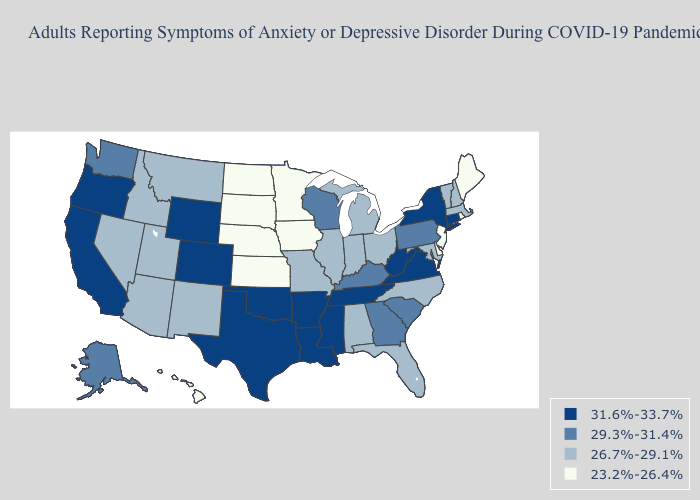Does West Virginia have the lowest value in the South?
Short answer required. No. Which states have the lowest value in the West?
Answer briefly. Hawaii. Among the states that border Wisconsin , does Michigan have the lowest value?
Short answer required. No. Which states have the lowest value in the MidWest?
Quick response, please. Iowa, Kansas, Minnesota, Nebraska, North Dakota, South Dakota. Name the states that have a value in the range 23.2%-26.4%?
Concise answer only. Delaware, Hawaii, Iowa, Kansas, Maine, Minnesota, Nebraska, New Jersey, North Dakota, Rhode Island, South Dakota. What is the highest value in the South ?
Concise answer only. 31.6%-33.7%. What is the value of Ohio?
Keep it brief. 26.7%-29.1%. Name the states that have a value in the range 31.6%-33.7%?
Be succinct. Arkansas, California, Colorado, Connecticut, Louisiana, Mississippi, New York, Oklahoma, Oregon, Tennessee, Texas, Virginia, West Virginia, Wyoming. Does South Dakota have the same value as North Dakota?
Quick response, please. Yes. Among the states that border Connecticut , does New York have the highest value?
Short answer required. Yes. Does the map have missing data?
Short answer required. No. What is the highest value in the USA?
Give a very brief answer. 31.6%-33.7%. Name the states that have a value in the range 31.6%-33.7%?
Be succinct. Arkansas, California, Colorado, Connecticut, Louisiana, Mississippi, New York, Oklahoma, Oregon, Tennessee, Texas, Virginia, West Virginia, Wyoming. Which states have the lowest value in the USA?
Keep it brief. Delaware, Hawaii, Iowa, Kansas, Maine, Minnesota, Nebraska, New Jersey, North Dakota, Rhode Island, South Dakota. What is the value of Kentucky?
Be succinct. 29.3%-31.4%. 